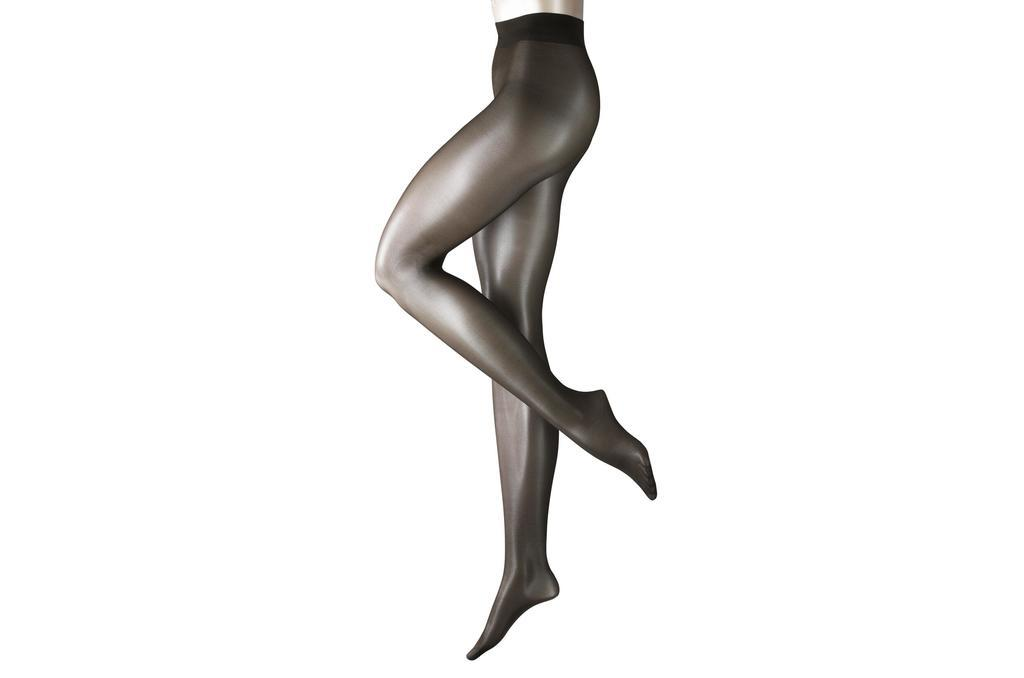What part of a person can be seen in the image? There are legs of a person in the image. What color is the background of the image? The background of the image is white. How many crows are sitting on the railway in the image? There is no railway or crow present in the image. What word is written on the person's shirt in the image? There is no shirt or word visible in the image; only the legs of a person are shown. 